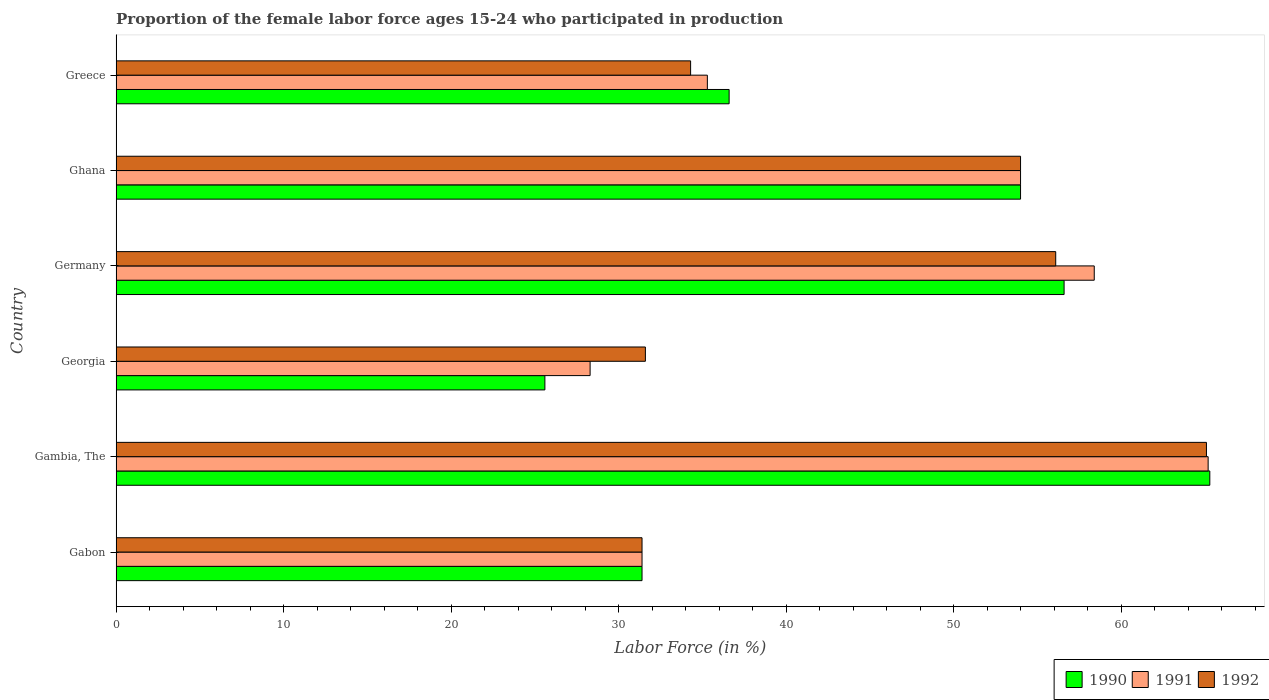How many different coloured bars are there?
Give a very brief answer. 3. How many groups of bars are there?
Keep it short and to the point. 6. How many bars are there on the 1st tick from the top?
Make the answer very short. 3. What is the label of the 2nd group of bars from the top?
Offer a terse response. Ghana. In how many cases, is the number of bars for a given country not equal to the number of legend labels?
Your answer should be compact. 0. What is the proportion of the female labor force who participated in production in 1990 in Gabon?
Your answer should be compact. 31.4. Across all countries, what is the maximum proportion of the female labor force who participated in production in 1992?
Make the answer very short. 65.1. Across all countries, what is the minimum proportion of the female labor force who participated in production in 1992?
Your response must be concise. 31.4. In which country was the proportion of the female labor force who participated in production in 1992 maximum?
Offer a terse response. Gambia, The. In which country was the proportion of the female labor force who participated in production in 1991 minimum?
Keep it short and to the point. Georgia. What is the total proportion of the female labor force who participated in production in 1991 in the graph?
Your answer should be very brief. 272.6. What is the difference between the proportion of the female labor force who participated in production in 1990 in Gambia, The and that in Germany?
Offer a terse response. 8.7. What is the difference between the proportion of the female labor force who participated in production in 1990 in Gambia, The and the proportion of the female labor force who participated in production in 1991 in Ghana?
Provide a short and direct response. 11.3. What is the average proportion of the female labor force who participated in production in 1990 per country?
Offer a terse response. 44.92. What is the difference between the proportion of the female labor force who participated in production in 1990 and proportion of the female labor force who participated in production in 1992 in Ghana?
Offer a very short reply. 0. What is the ratio of the proportion of the female labor force who participated in production in 1992 in Gabon to that in Georgia?
Give a very brief answer. 0.99. Is the difference between the proportion of the female labor force who participated in production in 1990 in Georgia and Germany greater than the difference between the proportion of the female labor force who participated in production in 1992 in Georgia and Germany?
Your answer should be very brief. No. What is the difference between the highest and the second highest proportion of the female labor force who participated in production in 1991?
Your answer should be very brief. 6.8. What is the difference between the highest and the lowest proportion of the female labor force who participated in production in 1991?
Ensure brevity in your answer.  36.9. Is the sum of the proportion of the female labor force who participated in production in 1990 in Gabon and Ghana greater than the maximum proportion of the female labor force who participated in production in 1991 across all countries?
Give a very brief answer. Yes. What does the 1st bar from the top in Greece represents?
Your answer should be compact. 1992. What does the 3rd bar from the bottom in Germany represents?
Offer a terse response. 1992. How many bars are there?
Your answer should be very brief. 18. What is the difference between two consecutive major ticks on the X-axis?
Your answer should be compact. 10. Are the values on the major ticks of X-axis written in scientific E-notation?
Offer a very short reply. No. Does the graph contain any zero values?
Provide a short and direct response. No. Does the graph contain grids?
Provide a short and direct response. No. What is the title of the graph?
Offer a very short reply. Proportion of the female labor force ages 15-24 who participated in production. Does "1983" appear as one of the legend labels in the graph?
Your answer should be very brief. No. What is the label or title of the X-axis?
Your answer should be compact. Labor Force (in %). What is the label or title of the Y-axis?
Provide a succinct answer. Country. What is the Labor Force (in %) of 1990 in Gabon?
Provide a short and direct response. 31.4. What is the Labor Force (in %) of 1991 in Gabon?
Offer a terse response. 31.4. What is the Labor Force (in %) of 1992 in Gabon?
Provide a succinct answer. 31.4. What is the Labor Force (in %) of 1990 in Gambia, The?
Offer a very short reply. 65.3. What is the Labor Force (in %) in 1991 in Gambia, The?
Your answer should be compact. 65.2. What is the Labor Force (in %) in 1992 in Gambia, The?
Offer a very short reply. 65.1. What is the Labor Force (in %) of 1990 in Georgia?
Keep it short and to the point. 25.6. What is the Labor Force (in %) of 1991 in Georgia?
Your answer should be compact. 28.3. What is the Labor Force (in %) of 1992 in Georgia?
Provide a succinct answer. 31.6. What is the Labor Force (in %) of 1990 in Germany?
Your response must be concise. 56.6. What is the Labor Force (in %) of 1991 in Germany?
Your answer should be compact. 58.4. What is the Labor Force (in %) in 1992 in Germany?
Your response must be concise. 56.1. What is the Labor Force (in %) in 1990 in Ghana?
Your response must be concise. 54. What is the Labor Force (in %) of 1991 in Ghana?
Give a very brief answer. 54. What is the Labor Force (in %) of 1992 in Ghana?
Provide a short and direct response. 54. What is the Labor Force (in %) in 1990 in Greece?
Ensure brevity in your answer.  36.6. What is the Labor Force (in %) of 1991 in Greece?
Give a very brief answer. 35.3. What is the Labor Force (in %) in 1992 in Greece?
Give a very brief answer. 34.3. Across all countries, what is the maximum Labor Force (in %) of 1990?
Offer a terse response. 65.3. Across all countries, what is the maximum Labor Force (in %) in 1991?
Give a very brief answer. 65.2. Across all countries, what is the maximum Labor Force (in %) of 1992?
Provide a succinct answer. 65.1. Across all countries, what is the minimum Labor Force (in %) of 1990?
Provide a succinct answer. 25.6. Across all countries, what is the minimum Labor Force (in %) in 1991?
Offer a very short reply. 28.3. Across all countries, what is the minimum Labor Force (in %) in 1992?
Keep it short and to the point. 31.4. What is the total Labor Force (in %) of 1990 in the graph?
Ensure brevity in your answer.  269.5. What is the total Labor Force (in %) in 1991 in the graph?
Ensure brevity in your answer.  272.6. What is the total Labor Force (in %) of 1992 in the graph?
Your answer should be compact. 272.5. What is the difference between the Labor Force (in %) of 1990 in Gabon and that in Gambia, The?
Ensure brevity in your answer.  -33.9. What is the difference between the Labor Force (in %) in 1991 in Gabon and that in Gambia, The?
Provide a short and direct response. -33.8. What is the difference between the Labor Force (in %) of 1992 in Gabon and that in Gambia, The?
Your answer should be compact. -33.7. What is the difference between the Labor Force (in %) in 1990 in Gabon and that in Germany?
Your answer should be compact. -25.2. What is the difference between the Labor Force (in %) in 1991 in Gabon and that in Germany?
Give a very brief answer. -27. What is the difference between the Labor Force (in %) in 1992 in Gabon and that in Germany?
Keep it short and to the point. -24.7. What is the difference between the Labor Force (in %) of 1990 in Gabon and that in Ghana?
Provide a succinct answer. -22.6. What is the difference between the Labor Force (in %) of 1991 in Gabon and that in Ghana?
Provide a succinct answer. -22.6. What is the difference between the Labor Force (in %) of 1992 in Gabon and that in Ghana?
Provide a succinct answer. -22.6. What is the difference between the Labor Force (in %) of 1990 in Gabon and that in Greece?
Offer a terse response. -5.2. What is the difference between the Labor Force (in %) of 1990 in Gambia, The and that in Georgia?
Offer a very short reply. 39.7. What is the difference between the Labor Force (in %) of 1991 in Gambia, The and that in Georgia?
Offer a very short reply. 36.9. What is the difference between the Labor Force (in %) in 1992 in Gambia, The and that in Georgia?
Your answer should be compact. 33.5. What is the difference between the Labor Force (in %) of 1992 in Gambia, The and that in Germany?
Offer a terse response. 9. What is the difference between the Labor Force (in %) in 1990 in Gambia, The and that in Ghana?
Provide a short and direct response. 11.3. What is the difference between the Labor Force (in %) in 1991 in Gambia, The and that in Ghana?
Your answer should be compact. 11.2. What is the difference between the Labor Force (in %) of 1990 in Gambia, The and that in Greece?
Ensure brevity in your answer.  28.7. What is the difference between the Labor Force (in %) of 1991 in Gambia, The and that in Greece?
Offer a terse response. 29.9. What is the difference between the Labor Force (in %) of 1992 in Gambia, The and that in Greece?
Make the answer very short. 30.8. What is the difference between the Labor Force (in %) in 1990 in Georgia and that in Germany?
Give a very brief answer. -31. What is the difference between the Labor Force (in %) of 1991 in Georgia and that in Germany?
Your answer should be compact. -30.1. What is the difference between the Labor Force (in %) of 1992 in Georgia and that in Germany?
Make the answer very short. -24.5. What is the difference between the Labor Force (in %) in 1990 in Georgia and that in Ghana?
Your response must be concise. -28.4. What is the difference between the Labor Force (in %) in 1991 in Georgia and that in Ghana?
Provide a succinct answer. -25.7. What is the difference between the Labor Force (in %) of 1992 in Georgia and that in Ghana?
Your answer should be very brief. -22.4. What is the difference between the Labor Force (in %) of 1990 in Georgia and that in Greece?
Provide a succinct answer. -11. What is the difference between the Labor Force (in %) in 1991 in Georgia and that in Greece?
Offer a very short reply. -7. What is the difference between the Labor Force (in %) in 1992 in Georgia and that in Greece?
Offer a very short reply. -2.7. What is the difference between the Labor Force (in %) in 1990 in Germany and that in Ghana?
Your answer should be very brief. 2.6. What is the difference between the Labor Force (in %) of 1992 in Germany and that in Ghana?
Your answer should be very brief. 2.1. What is the difference between the Labor Force (in %) of 1991 in Germany and that in Greece?
Offer a very short reply. 23.1. What is the difference between the Labor Force (in %) in 1992 in Germany and that in Greece?
Ensure brevity in your answer.  21.8. What is the difference between the Labor Force (in %) of 1992 in Ghana and that in Greece?
Offer a terse response. 19.7. What is the difference between the Labor Force (in %) of 1990 in Gabon and the Labor Force (in %) of 1991 in Gambia, The?
Make the answer very short. -33.8. What is the difference between the Labor Force (in %) in 1990 in Gabon and the Labor Force (in %) in 1992 in Gambia, The?
Provide a succinct answer. -33.7. What is the difference between the Labor Force (in %) in 1991 in Gabon and the Labor Force (in %) in 1992 in Gambia, The?
Provide a succinct answer. -33.7. What is the difference between the Labor Force (in %) of 1990 in Gabon and the Labor Force (in %) of 1991 in Georgia?
Your response must be concise. 3.1. What is the difference between the Labor Force (in %) in 1990 in Gabon and the Labor Force (in %) in 1991 in Germany?
Your answer should be compact. -27. What is the difference between the Labor Force (in %) of 1990 in Gabon and the Labor Force (in %) of 1992 in Germany?
Your answer should be very brief. -24.7. What is the difference between the Labor Force (in %) of 1991 in Gabon and the Labor Force (in %) of 1992 in Germany?
Provide a succinct answer. -24.7. What is the difference between the Labor Force (in %) in 1990 in Gabon and the Labor Force (in %) in 1991 in Ghana?
Make the answer very short. -22.6. What is the difference between the Labor Force (in %) of 1990 in Gabon and the Labor Force (in %) of 1992 in Ghana?
Your answer should be very brief. -22.6. What is the difference between the Labor Force (in %) in 1991 in Gabon and the Labor Force (in %) in 1992 in Ghana?
Give a very brief answer. -22.6. What is the difference between the Labor Force (in %) of 1990 in Gabon and the Labor Force (in %) of 1991 in Greece?
Keep it short and to the point. -3.9. What is the difference between the Labor Force (in %) in 1990 in Gabon and the Labor Force (in %) in 1992 in Greece?
Provide a short and direct response. -2.9. What is the difference between the Labor Force (in %) of 1991 in Gabon and the Labor Force (in %) of 1992 in Greece?
Ensure brevity in your answer.  -2.9. What is the difference between the Labor Force (in %) in 1990 in Gambia, The and the Labor Force (in %) in 1992 in Georgia?
Make the answer very short. 33.7. What is the difference between the Labor Force (in %) in 1991 in Gambia, The and the Labor Force (in %) in 1992 in Georgia?
Your response must be concise. 33.6. What is the difference between the Labor Force (in %) in 1990 in Gambia, The and the Labor Force (in %) in 1992 in Ghana?
Keep it short and to the point. 11.3. What is the difference between the Labor Force (in %) of 1991 in Gambia, The and the Labor Force (in %) of 1992 in Ghana?
Keep it short and to the point. 11.2. What is the difference between the Labor Force (in %) of 1990 in Gambia, The and the Labor Force (in %) of 1991 in Greece?
Provide a succinct answer. 30. What is the difference between the Labor Force (in %) in 1990 in Gambia, The and the Labor Force (in %) in 1992 in Greece?
Ensure brevity in your answer.  31. What is the difference between the Labor Force (in %) in 1991 in Gambia, The and the Labor Force (in %) in 1992 in Greece?
Offer a very short reply. 30.9. What is the difference between the Labor Force (in %) in 1990 in Georgia and the Labor Force (in %) in 1991 in Germany?
Your answer should be compact. -32.8. What is the difference between the Labor Force (in %) of 1990 in Georgia and the Labor Force (in %) of 1992 in Germany?
Your answer should be compact. -30.5. What is the difference between the Labor Force (in %) in 1991 in Georgia and the Labor Force (in %) in 1992 in Germany?
Give a very brief answer. -27.8. What is the difference between the Labor Force (in %) in 1990 in Georgia and the Labor Force (in %) in 1991 in Ghana?
Offer a very short reply. -28.4. What is the difference between the Labor Force (in %) in 1990 in Georgia and the Labor Force (in %) in 1992 in Ghana?
Give a very brief answer. -28.4. What is the difference between the Labor Force (in %) of 1991 in Georgia and the Labor Force (in %) of 1992 in Ghana?
Your answer should be very brief. -25.7. What is the difference between the Labor Force (in %) in 1990 in Germany and the Labor Force (in %) in 1992 in Ghana?
Provide a short and direct response. 2.6. What is the difference between the Labor Force (in %) of 1991 in Germany and the Labor Force (in %) of 1992 in Ghana?
Your answer should be very brief. 4.4. What is the difference between the Labor Force (in %) in 1990 in Germany and the Labor Force (in %) in 1991 in Greece?
Provide a succinct answer. 21.3. What is the difference between the Labor Force (in %) of 1990 in Germany and the Labor Force (in %) of 1992 in Greece?
Ensure brevity in your answer.  22.3. What is the difference between the Labor Force (in %) in 1991 in Germany and the Labor Force (in %) in 1992 in Greece?
Make the answer very short. 24.1. What is the difference between the Labor Force (in %) in 1990 in Ghana and the Labor Force (in %) in 1991 in Greece?
Make the answer very short. 18.7. What is the difference between the Labor Force (in %) in 1990 in Ghana and the Labor Force (in %) in 1992 in Greece?
Your answer should be compact. 19.7. What is the difference between the Labor Force (in %) in 1991 in Ghana and the Labor Force (in %) in 1992 in Greece?
Provide a short and direct response. 19.7. What is the average Labor Force (in %) in 1990 per country?
Make the answer very short. 44.92. What is the average Labor Force (in %) of 1991 per country?
Offer a terse response. 45.43. What is the average Labor Force (in %) in 1992 per country?
Your answer should be very brief. 45.42. What is the difference between the Labor Force (in %) in 1990 and Labor Force (in %) in 1991 in Gabon?
Ensure brevity in your answer.  0. What is the difference between the Labor Force (in %) in 1991 and Labor Force (in %) in 1992 in Gabon?
Provide a succinct answer. 0. What is the difference between the Labor Force (in %) of 1990 and Labor Force (in %) of 1991 in Gambia, The?
Your response must be concise. 0.1. What is the difference between the Labor Force (in %) of 1990 and Labor Force (in %) of 1992 in Gambia, The?
Provide a short and direct response. 0.2. What is the difference between the Labor Force (in %) in 1991 and Labor Force (in %) in 1992 in Gambia, The?
Keep it short and to the point. 0.1. What is the difference between the Labor Force (in %) in 1990 and Labor Force (in %) in 1992 in Georgia?
Make the answer very short. -6. What is the difference between the Labor Force (in %) of 1990 and Labor Force (in %) of 1992 in Germany?
Your answer should be compact. 0.5. What is the difference between the Labor Force (in %) in 1991 and Labor Force (in %) in 1992 in Germany?
Your answer should be compact. 2.3. What is the difference between the Labor Force (in %) in 1990 and Labor Force (in %) in 1991 in Ghana?
Your answer should be compact. 0. What is the difference between the Labor Force (in %) in 1991 and Labor Force (in %) in 1992 in Ghana?
Your response must be concise. 0. What is the ratio of the Labor Force (in %) in 1990 in Gabon to that in Gambia, The?
Your response must be concise. 0.48. What is the ratio of the Labor Force (in %) in 1991 in Gabon to that in Gambia, The?
Provide a short and direct response. 0.48. What is the ratio of the Labor Force (in %) in 1992 in Gabon to that in Gambia, The?
Provide a succinct answer. 0.48. What is the ratio of the Labor Force (in %) of 1990 in Gabon to that in Georgia?
Provide a succinct answer. 1.23. What is the ratio of the Labor Force (in %) of 1991 in Gabon to that in Georgia?
Provide a succinct answer. 1.11. What is the ratio of the Labor Force (in %) of 1990 in Gabon to that in Germany?
Offer a very short reply. 0.55. What is the ratio of the Labor Force (in %) of 1991 in Gabon to that in Germany?
Your answer should be compact. 0.54. What is the ratio of the Labor Force (in %) of 1992 in Gabon to that in Germany?
Ensure brevity in your answer.  0.56. What is the ratio of the Labor Force (in %) of 1990 in Gabon to that in Ghana?
Make the answer very short. 0.58. What is the ratio of the Labor Force (in %) in 1991 in Gabon to that in Ghana?
Make the answer very short. 0.58. What is the ratio of the Labor Force (in %) in 1992 in Gabon to that in Ghana?
Keep it short and to the point. 0.58. What is the ratio of the Labor Force (in %) in 1990 in Gabon to that in Greece?
Keep it short and to the point. 0.86. What is the ratio of the Labor Force (in %) in 1991 in Gabon to that in Greece?
Your answer should be very brief. 0.89. What is the ratio of the Labor Force (in %) of 1992 in Gabon to that in Greece?
Provide a short and direct response. 0.92. What is the ratio of the Labor Force (in %) in 1990 in Gambia, The to that in Georgia?
Provide a succinct answer. 2.55. What is the ratio of the Labor Force (in %) in 1991 in Gambia, The to that in Georgia?
Keep it short and to the point. 2.3. What is the ratio of the Labor Force (in %) in 1992 in Gambia, The to that in Georgia?
Your response must be concise. 2.06. What is the ratio of the Labor Force (in %) in 1990 in Gambia, The to that in Germany?
Make the answer very short. 1.15. What is the ratio of the Labor Force (in %) of 1991 in Gambia, The to that in Germany?
Offer a terse response. 1.12. What is the ratio of the Labor Force (in %) in 1992 in Gambia, The to that in Germany?
Ensure brevity in your answer.  1.16. What is the ratio of the Labor Force (in %) in 1990 in Gambia, The to that in Ghana?
Make the answer very short. 1.21. What is the ratio of the Labor Force (in %) of 1991 in Gambia, The to that in Ghana?
Your answer should be compact. 1.21. What is the ratio of the Labor Force (in %) of 1992 in Gambia, The to that in Ghana?
Provide a succinct answer. 1.21. What is the ratio of the Labor Force (in %) of 1990 in Gambia, The to that in Greece?
Your answer should be compact. 1.78. What is the ratio of the Labor Force (in %) in 1991 in Gambia, The to that in Greece?
Ensure brevity in your answer.  1.85. What is the ratio of the Labor Force (in %) of 1992 in Gambia, The to that in Greece?
Your response must be concise. 1.9. What is the ratio of the Labor Force (in %) in 1990 in Georgia to that in Germany?
Provide a short and direct response. 0.45. What is the ratio of the Labor Force (in %) in 1991 in Georgia to that in Germany?
Your response must be concise. 0.48. What is the ratio of the Labor Force (in %) of 1992 in Georgia to that in Germany?
Keep it short and to the point. 0.56. What is the ratio of the Labor Force (in %) of 1990 in Georgia to that in Ghana?
Your answer should be compact. 0.47. What is the ratio of the Labor Force (in %) in 1991 in Georgia to that in Ghana?
Provide a succinct answer. 0.52. What is the ratio of the Labor Force (in %) in 1992 in Georgia to that in Ghana?
Provide a short and direct response. 0.59. What is the ratio of the Labor Force (in %) of 1990 in Georgia to that in Greece?
Provide a succinct answer. 0.7. What is the ratio of the Labor Force (in %) in 1991 in Georgia to that in Greece?
Offer a very short reply. 0.8. What is the ratio of the Labor Force (in %) of 1992 in Georgia to that in Greece?
Offer a very short reply. 0.92. What is the ratio of the Labor Force (in %) of 1990 in Germany to that in Ghana?
Offer a very short reply. 1.05. What is the ratio of the Labor Force (in %) in 1991 in Germany to that in Ghana?
Ensure brevity in your answer.  1.08. What is the ratio of the Labor Force (in %) in 1992 in Germany to that in Ghana?
Your answer should be compact. 1.04. What is the ratio of the Labor Force (in %) of 1990 in Germany to that in Greece?
Your answer should be very brief. 1.55. What is the ratio of the Labor Force (in %) of 1991 in Germany to that in Greece?
Make the answer very short. 1.65. What is the ratio of the Labor Force (in %) in 1992 in Germany to that in Greece?
Your response must be concise. 1.64. What is the ratio of the Labor Force (in %) in 1990 in Ghana to that in Greece?
Provide a short and direct response. 1.48. What is the ratio of the Labor Force (in %) of 1991 in Ghana to that in Greece?
Ensure brevity in your answer.  1.53. What is the ratio of the Labor Force (in %) of 1992 in Ghana to that in Greece?
Provide a succinct answer. 1.57. What is the difference between the highest and the second highest Labor Force (in %) of 1990?
Your answer should be very brief. 8.7. What is the difference between the highest and the lowest Labor Force (in %) in 1990?
Provide a short and direct response. 39.7. What is the difference between the highest and the lowest Labor Force (in %) of 1991?
Provide a succinct answer. 36.9. What is the difference between the highest and the lowest Labor Force (in %) of 1992?
Make the answer very short. 33.7. 